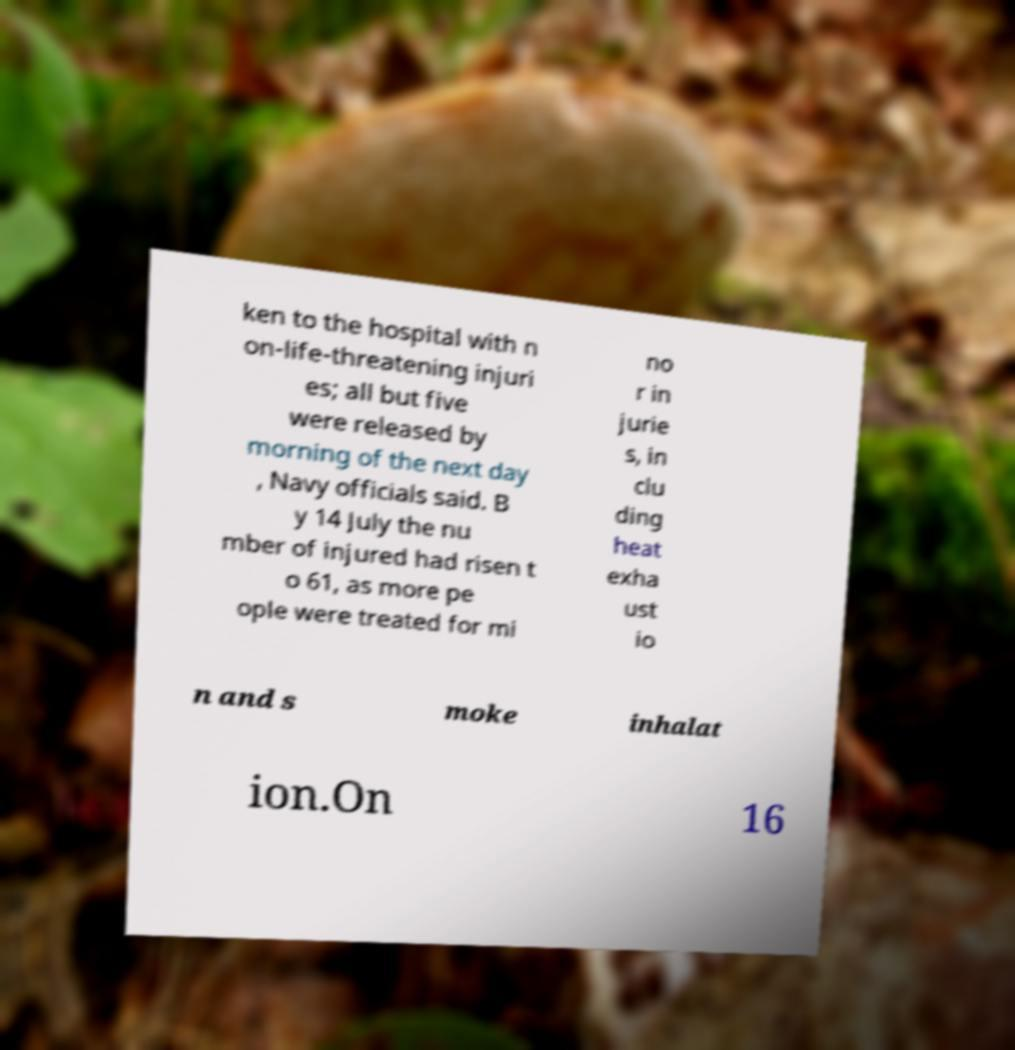Could you extract and type out the text from this image? ken to the hospital with n on-life-threatening injuri es; all but five were released by morning of the next day , Navy officials said. B y 14 July the nu mber of injured had risen t o 61, as more pe ople were treated for mi no r in jurie s, in clu ding heat exha ust io n and s moke inhalat ion.On 16 